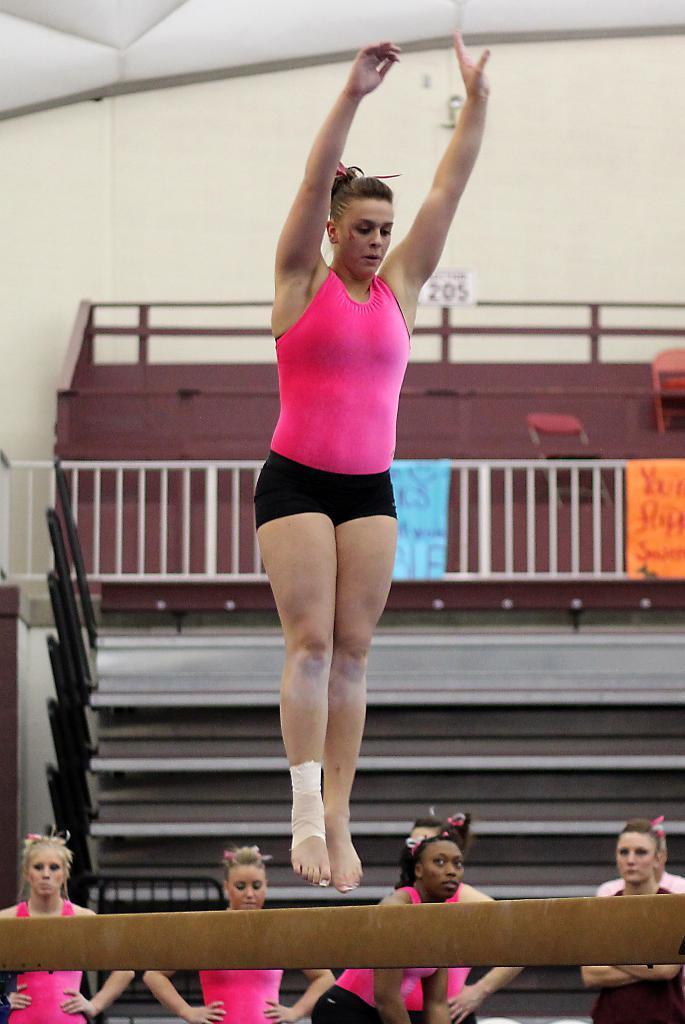Could you give a brief overview of what you see in this image? In this image I can see a woman jumping onto a balance beam, I can see four other women at the bottom of the image. I can see stairs grills, chairs and a wooden wall behind these people. 